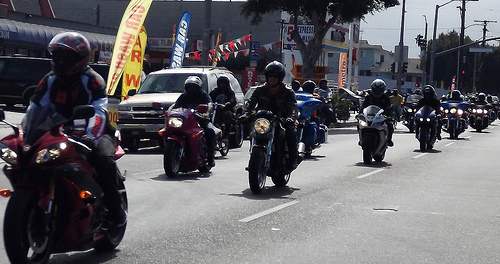<image>
Can you confirm if the tree is behind the building? No. The tree is not behind the building. From this viewpoint, the tree appears to be positioned elsewhere in the scene. Where is the bike in relation to the road? Is it above the road? No. The bike is not positioned above the road. The vertical arrangement shows a different relationship. 